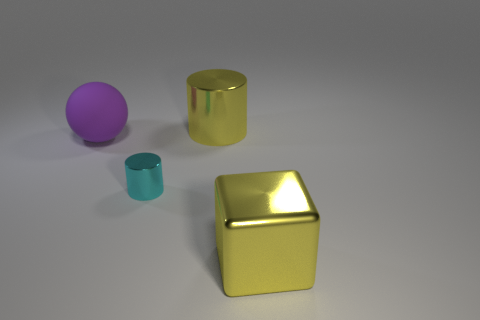Are there any other things that are the same shape as the purple rubber thing?
Offer a very short reply. No. What material is the cylinder on the left side of the big metal thing that is left of the large shiny object that is to the right of the large shiny cylinder?
Your response must be concise. Metal. Is there a red object that has the same size as the cyan shiny thing?
Your answer should be very brief. No. There is a yellow cylinder that is the same size as the rubber object; what is its material?
Give a very brief answer. Metal. What shape is the big yellow metallic object in front of the cyan cylinder?
Ensure brevity in your answer.  Cube. Does the large purple ball that is behind the cyan thing have the same material as the cylinder that is in front of the large rubber thing?
Ensure brevity in your answer.  No. What number of big yellow objects have the same shape as the large purple thing?
Offer a terse response. 0. What material is the thing that is the same color as the large block?
Provide a short and direct response. Metal. How many things are large cyan objects or objects on the left side of the tiny cyan metal object?
Provide a succinct answer. 1. What material is the large ball?
Give a very brief answer. Rubber. 